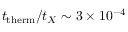Convert formula to latex. <formula><loc_0><loc_0><loc_500><loc_500>t _ { t h e r m } / t _ { X } \sim 3 \times 1 0 ^ { - 4 }</formula> 